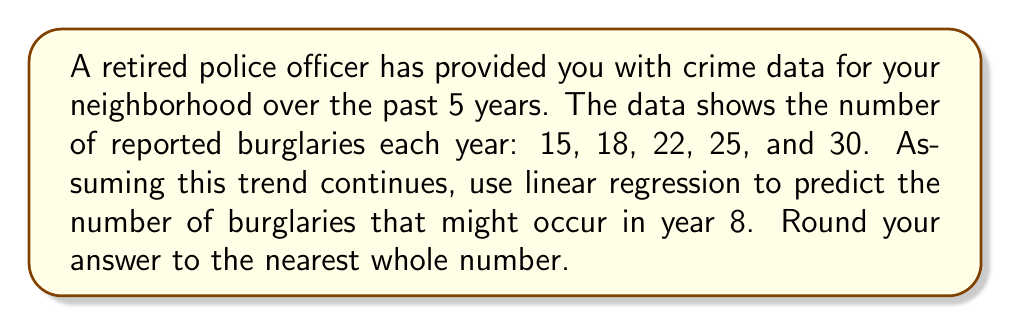Help me with this question. To solve this problem, we'll use linear regression to find the line of best fit for the given data points and then use that line to predict the number of burglaries in year 8.

1. Let's define our variables:
   $x$: year number (1, 2, 3, 4, 5)
   $y$: number of burglaries

2. We need to calculate the following sums:
   $\sum x = 1 + 2 + 3 + 4 + 5 = 15$
   $\sum y = 15 + 18 + 22 + 25 + 30 = 110$
   $\sum xy = (1)(15) + (2)(18) + (3)(22) + (4)(25) + (5)(30) = 370$
   $\sum x^2 = 1^2 + 2^2 + 3^2 + 4^2 + 5^2 = 55$
   $n = 5$ (number of data points)

3. Use the linear regression formula to find the slope (m) and y-intercept (b):

   $m = \frac{n\sum xy - \sum x \sum y}{n\sum x^2 - (\sum x)^2}$

   $m = \frac{5(370) - (15)(110)}{5(55) - (15)^2} = \frac{1850 - 1650}{275 - 225} = \frac{200}{50} = 4$

   $b = \frac{\sum y - m\sum x}{n} = \frac{110 - 4(15)}{5} = \frac{110 - 60}{5} = 10$

4. The equation of the line of best fit is:
   $y = mx + b = 4x + 10$

5. To predict the number of burglaries in year 8, substitute $x = 8$ into the equation:
   $y = 4(8) + 10 = 32 + 10 = 42$

Therefore, the predicted number of burglaries in year 8 is 42.
Answer: 42 burglaries 